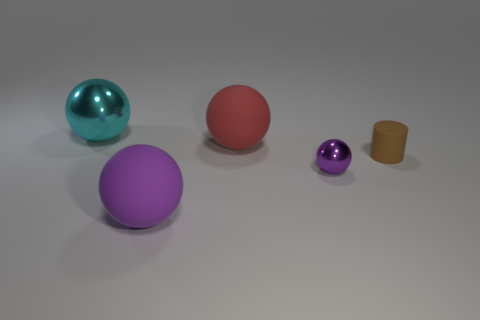Subtract 1 spheres. How many spheres are left? 3 Add 1 big red matte spheres. How many objects exist? 6 Subtract all balls. How many objects are left? 1 Add 3 big purple matte spheres. How many big purple matte spheres are left? 4 Add 2 shiny objects. How many shiny objects exist? 4 Subtract 0 yellow blocks. How many objects are left? 5 Subtract all small brown cylinders. Subtract all large cyan metallic balls. How many objects are left? 3 